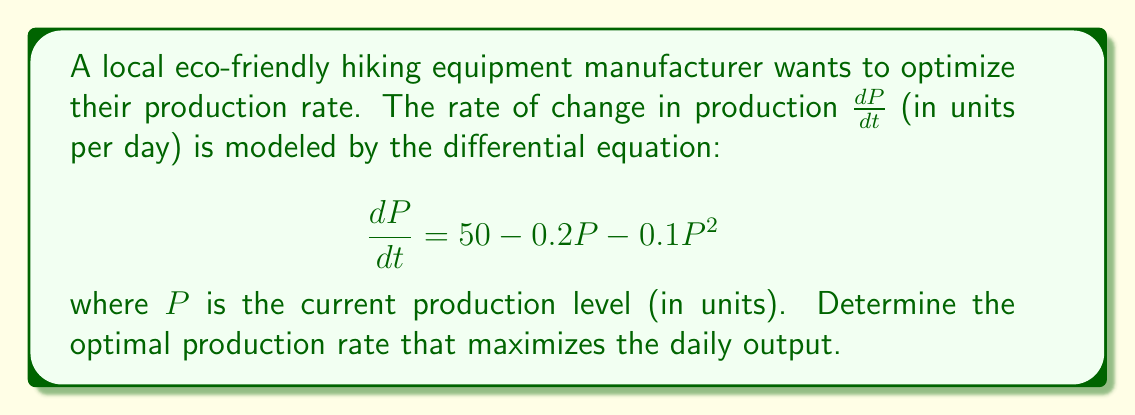What is the answer to this math problem? To find the optimal production rate, we need to determine the maximum point of the production rate function. This occurs when the rate of change in production $\frac{dP}{dt}$ is zero.

1. Set the differential equation equal to zero:
   $$50 - 0.2P - 0.1P^2 = 0$$

2. Rearrange the equation to standard quadratic form:
   $$0.1P^2 + 0.2P - 50 = 0$$

3. Solve the quadratic equation using the quadratic formula:
   $$P = \frac{-b \pm \sqrt{b^2 - 4ac}}{2a}$$
   where $a = 0.1$, $b = 0.2$, and $c = -50$

4. Substitute the values:
   $$P = \frac{-0.2 \pm \sqrt{0.2^2 - 4(0.1)(-50)}}{2(0.1)}$$

5. Simplify:
   $$P = \frac{-0.2 \pm \sqrt{0.04 + 20}}{0.2} = \frac{-0.2 \pm \sqrt{20.04}}{0.2}$$

6. Calculate the two roots:
   $$P_1 = \frac{-0.2 + \sqrt{20.04}}{0.2} \approx 22.18$$
   $$P_2 = \frac{-0.2 - \sqrt{20.04}}{0.2} \approx -24.18$$

7. Since production cannot be negative, we discard the negative solution.

Therefore, the optimal production rate is approximately 22.18 units per day.
Answer: The optimal production rate is approximately 22.18 units per day. 